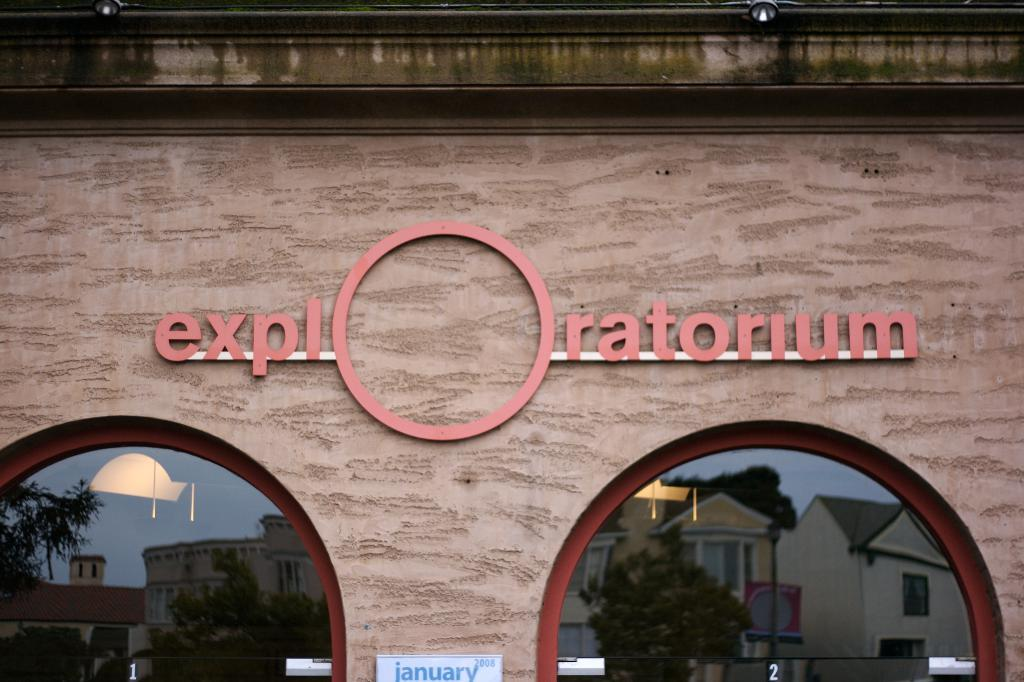What is the main object in the image? There is a board in the image. What is written on the board? There is a name board on the board. What can be seen through the glasses in the image? Buildings and trees are visible through the glasses. Where are the lights located in the image? The lights are at the top of the image. How many sheep are visible through the glasses in the image? There are no sheep visible through the glasses in the image. What is the profit margin of the business associated with the name board on the board? There is no information about a business or profit margin in the image. 